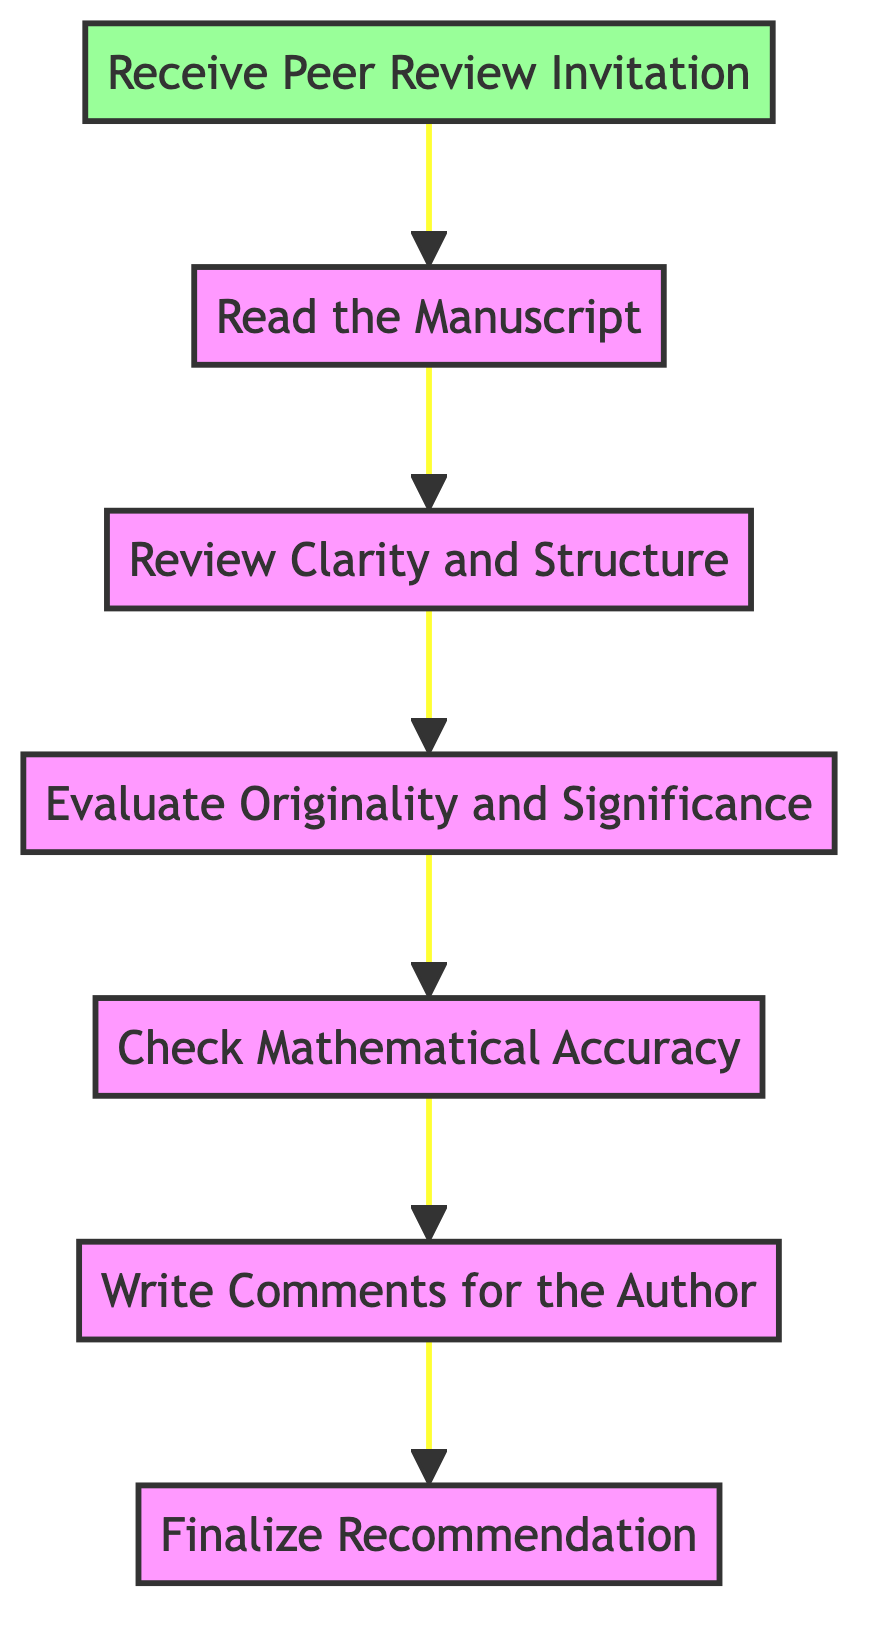What is the first step in the peer review process? The first step, as shown in the diagram, is "Receive Peer Review Invitation." This is where the peer reviewer accepts the invitation from the journal to review a submitted article.
Answer: Receive Peer Review Invitation How many steps are there in the peer review process? By counting the nodes in the diagram, we find there are a total of 7 steps, starting from receiving the invitation to finalizing the recommendation.
Answer: 7 What node comes after "Read the Manuscript"? The node that follows "Read the Manuscript" is "Review Clarity and Structure." This indicates the progression to examining the manuscript's organizational quality after reading it.
Answer: Review Clarity and Structure What is the last action taken in the peer review process? The last action indicated in the flow chart is "Finalize Recommendation," where the reviewer compiles observations and communicates their recommendation to the editor.
Answer: Finalize Recommendation Which step involves checking for errors in calculations? The step that specifically involves ensuring theorems, proofs, and calculations are correct is "Check Mathematical Accuracy." This emphasizes the verification of mathematical correctness during the review.
Answer: Check Mathematical Accuracy What step evaluates the novelty of the research? The step assessing the originality of the research is "Evaluate Originality and Significance." This focuses on understanding the contribution the research makes to the mathematical field.
Answer: Evaluate Originality and Significance At which point do authors receive constructive feedback? Authors receive constructive feedback in the step "Write Comments for the Author." This step is dedicated to providing insights on strengths and weaknesses in the manuscript.
Answer: Write Comments for the Author What is the relationship between "Evaluate Originality and Significance" and "Check Mathematical Accuracy"? "Evaluate Originality and Significance" precedes "Check Mathematical Accuracy" in the flow. This indicates that originality is evaluated before verifying mathematical correctness in the process.
Answer: Precedes What is the significance of the arrow direction in this flow chart? The arrow direction signifies the flow of the review process, indicating the sequential nature of each step from receiving the invitation to finalizing the recommendation.
Answer: Sequential flow 